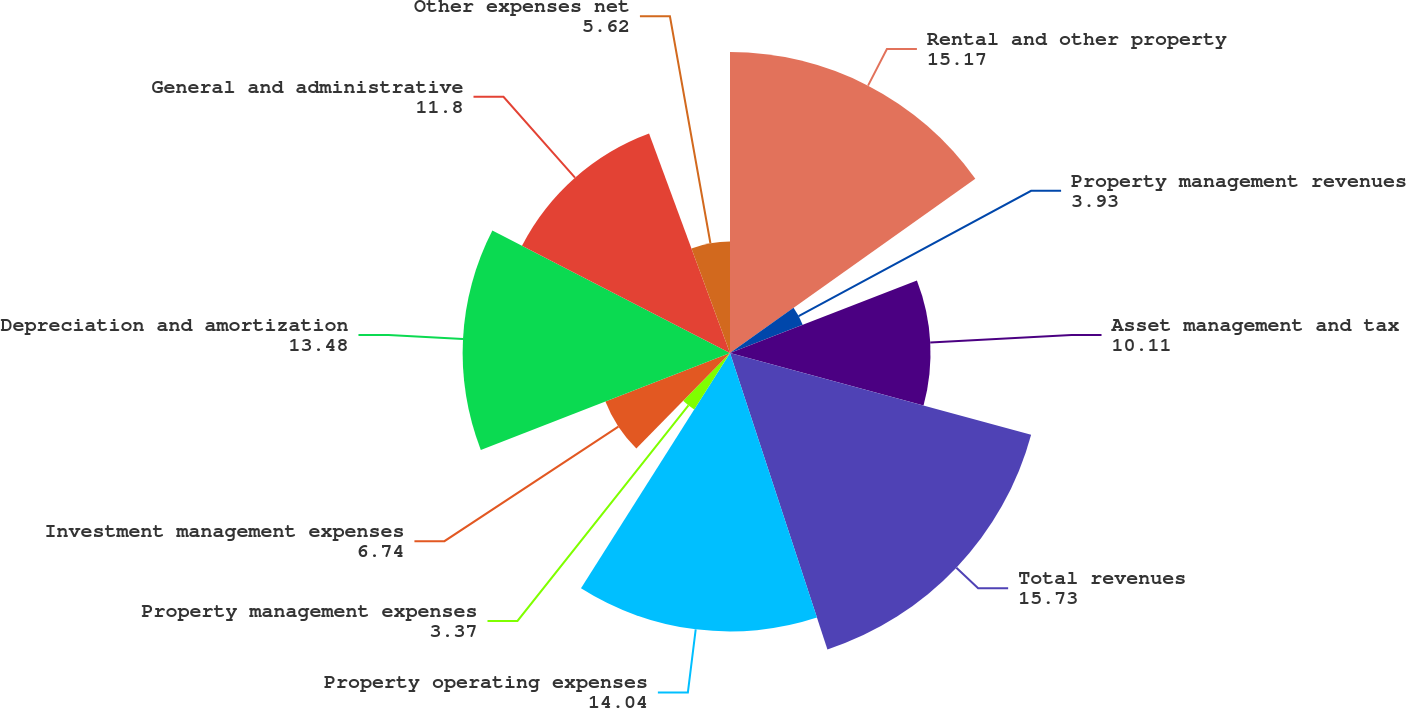Convert chart. <chart><loc_0><loc_0><loc_500><loc_500><pie_chart><fcel>Rental and other property<fcel>Property management revenues<fcel>Asset management and tax<fcel>Total revenues<fcel>Property operating expenses<fcel>Property management expenses<fcel>Investment management expenses<fcel>Depreciation and amortization<fcel>General and administrative<fcel>Other expenses net<nl><fcel>15.17%<fcel>3.93%<fcel>10.11%<fcel>15.73%<fcel>14.04%<fcel>3.37%<fcel>6.74%<fcel>13.48%<fcel>11.8%<fcel>5.62%<nl></chart> 